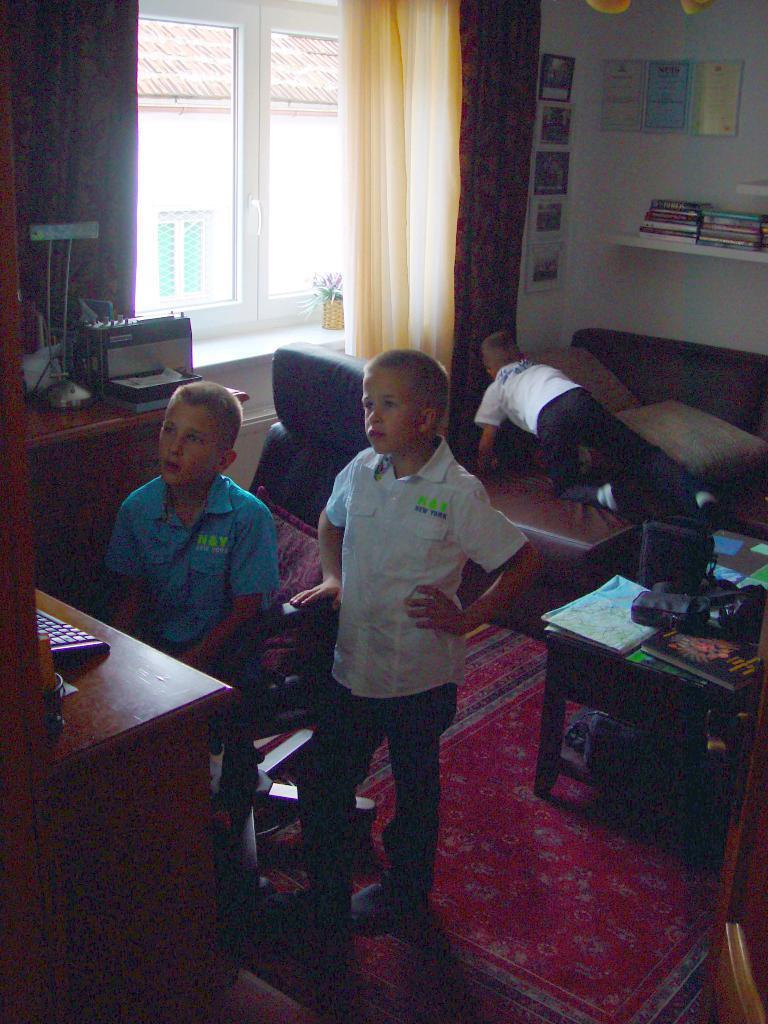How would you summarize this image in a sentence or two? In this picture we can see three boys, one boy is sitting on a chair and the other is leaning to the chair and the both are looking at something and the third boy is searching for something and in between them we can see table on an table we have books, papers and on left side we can see glass window, a flower vase,curtains and at last we have rack full of books and wall full of frames and from window we can see a house. 